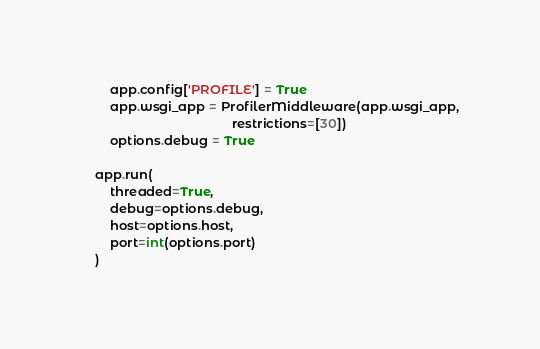<code> <loc_0><loc_0><loc_500><loc_500><_Python_>
        app.config['PROFILE'] = True
        app.wsgi_app = ProfilerMiddleware(app.wsgi_app,
                                          restrictions=[30])
        options.debug = True

    app.run(
        threaded=True,
        debug=options.debug,
        host=options.host,
        port=int(options.port)
    )
</code> 